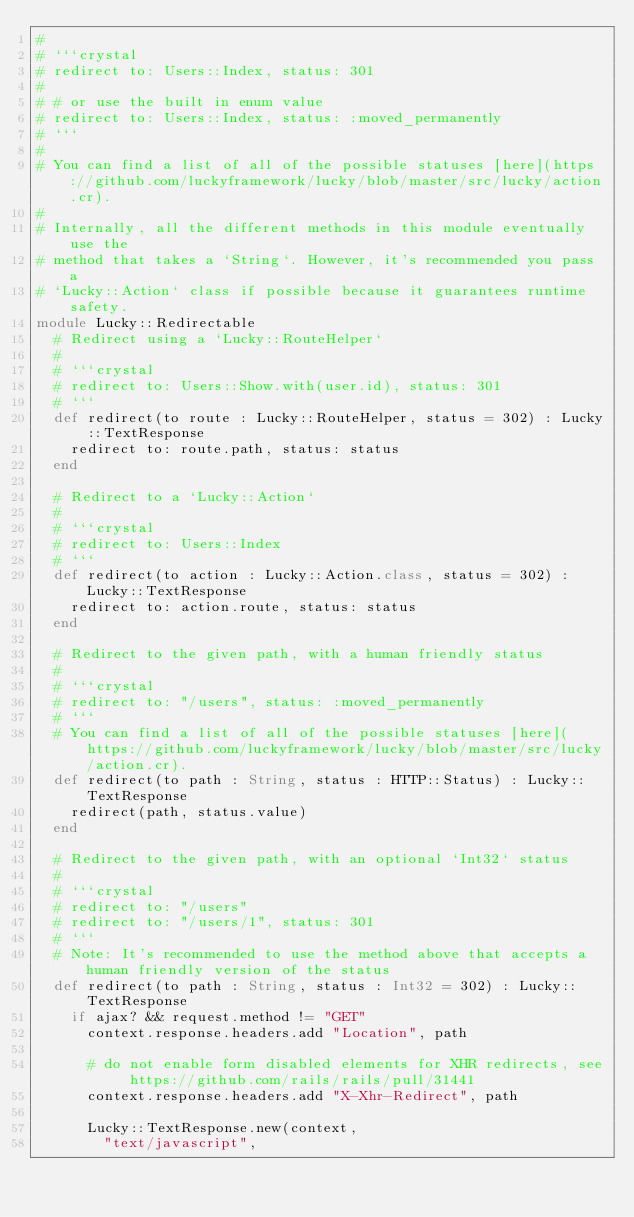Convert code to text. <code><loc_0><loc_0><loc_500><loc_500><_Crystal_>#
# ```crystal
# redirect to: Users::Index, status: 301
#
# # or use the built in enum value
# redirect to: Users::Index, status: :moved_permanently
# ```
#
# You can find a list of all of the possible statuses [here](https://github.com/luckyframework/lucky/blob/master/src/lucky/action.cr).
#
# Internally, all the different methods in this module eventually use the
# method that takes a `String`. However, it's recommended you pass a
# `Lucky::Action` class if possible because it guarantees runtime safety.
module Lucky::Redirectable
  # Redirect using a `Lucky::RouteHelper`
  #
  # ```crystal
  # redirect to: Users::Show.with(user.id), status: 301
  # ```
  def redirect(to route : Lucky::RouteHelper, status = 302) : Lucky::TextResponse
    redirect to: route.path, status: status
  end

  # Redirect to a `Lucky::Action`
  #
  # ```crystal
  # redirect to: Users::Index
  # ```
  def redirect(to action : Lucky::Action.class, status = 302) : Lucky::TextResponse
    redirect to: action.route, status: status
  end

  # Redirect to the given path, with a human friendly status
  #
  # ```crystal
  # redirect to: "/users", status: :moved_permanently
  # ```
  # You can find a list of all of the possible statuses [here](https://github.com/luckyframework/lucky/blob/master/src/lucky/action.cr).
  def redirect(to path : String, status : HTTP::Status) : Lucky::TextResponse
    redirect(path, status.value)
  end

  # Redirect to the given path, with an optional `Int32` status
  #
  # ```crystal
  # redirect to: "/users"
  # redirect to: "/users/1", status: 301
  # ```
  # Note: It's recommended to use the method above that accepts a human friendly version of the status
  def redirect(to path : String, status : Int32 = 302) : Lucky::TextResponse
    if ajax? && request.method != "GET"
      context.response.headers.add "Location", path

      # do not enable form disabled elements for XHR redirects, see https://github.com/rails/rails/pull/31441
      context.response.headers.add "X-Xhr-Redirect", path

      Lucky::TextResponse.new(context,
        "text/javascript",</code> 